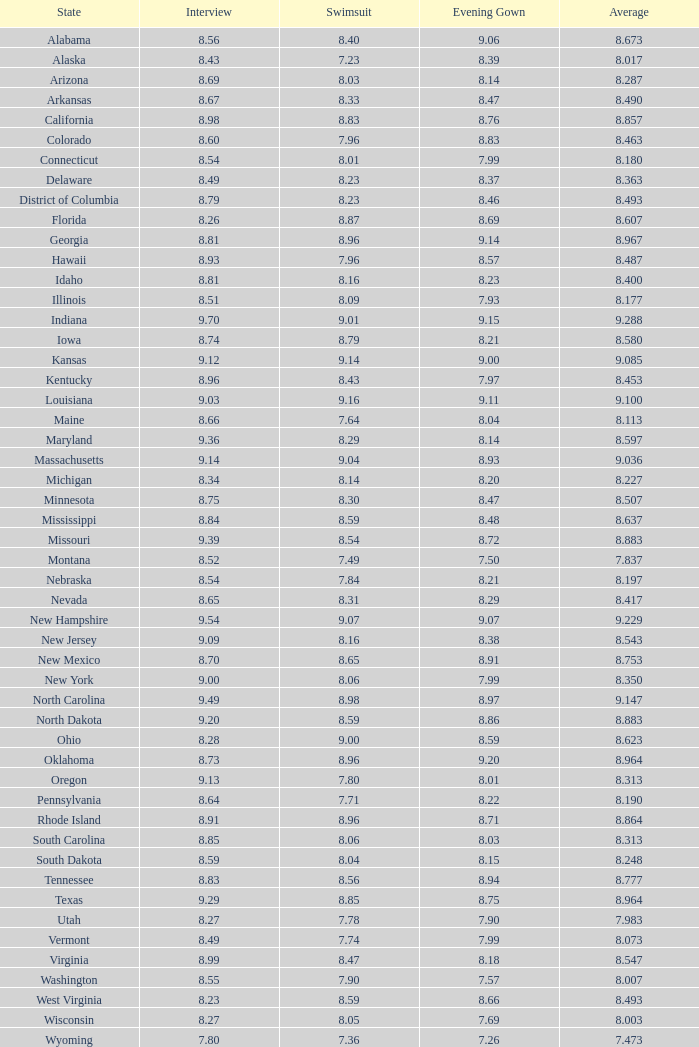7 and swimwear below Alabama. 